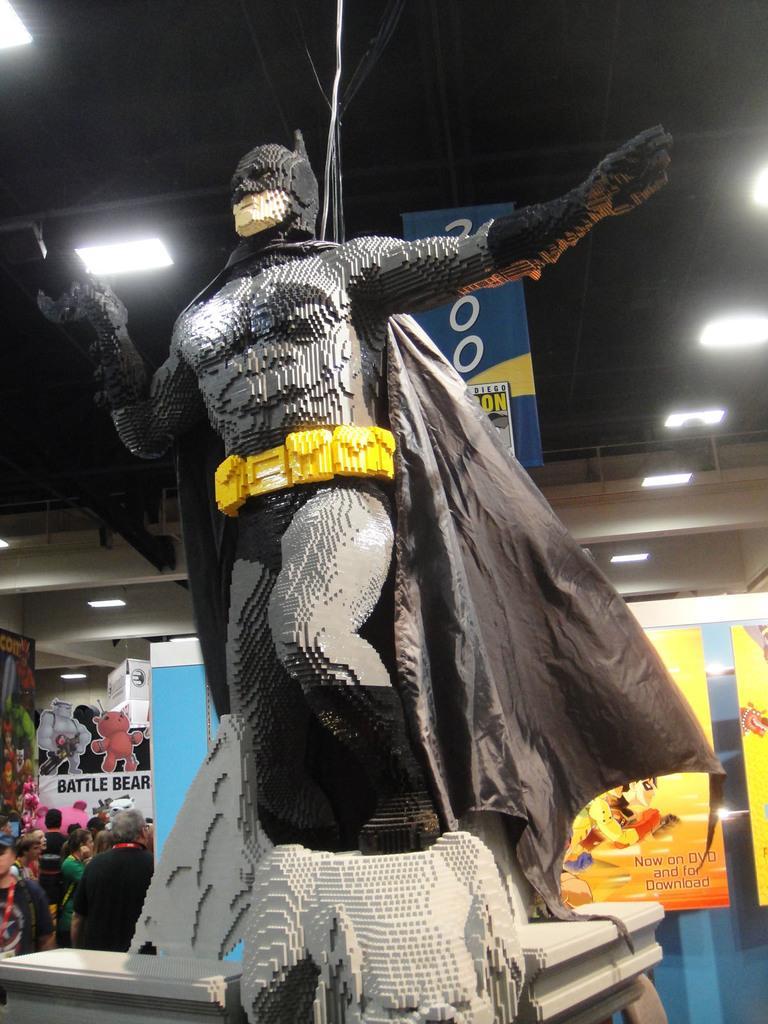Describe this image in one or two sentences. In this picture we can see a statue on a platform and in the background we can see people, posters, lights, rods and some objects. 